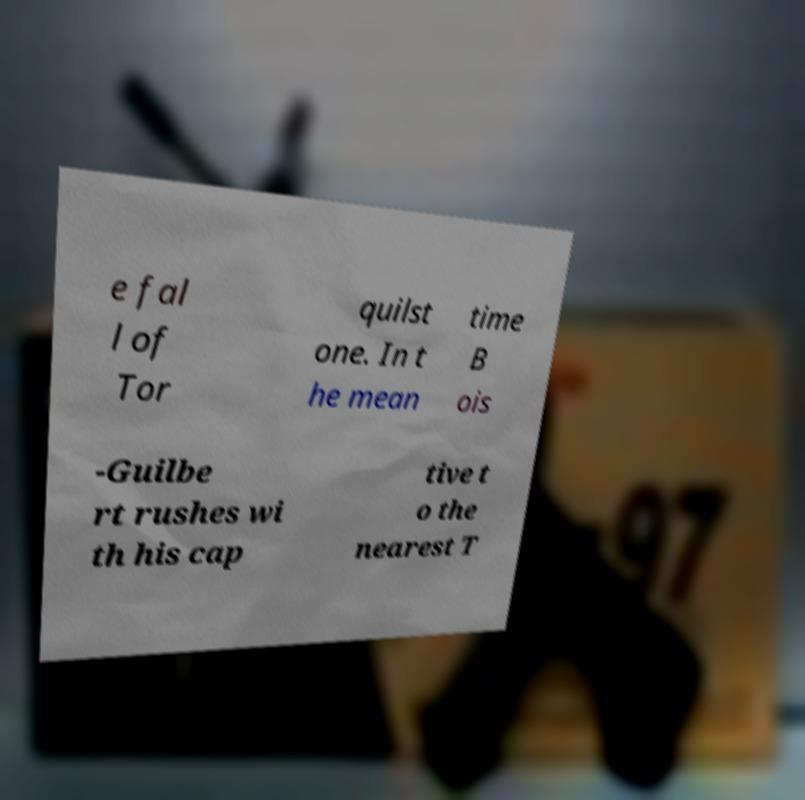Please read and relay the text visible in this image. What does it say? e fal l of Tor quilst one. In t he mean time B ois -Guilbe rt rushes wi th his cap tive t o the nearest T 